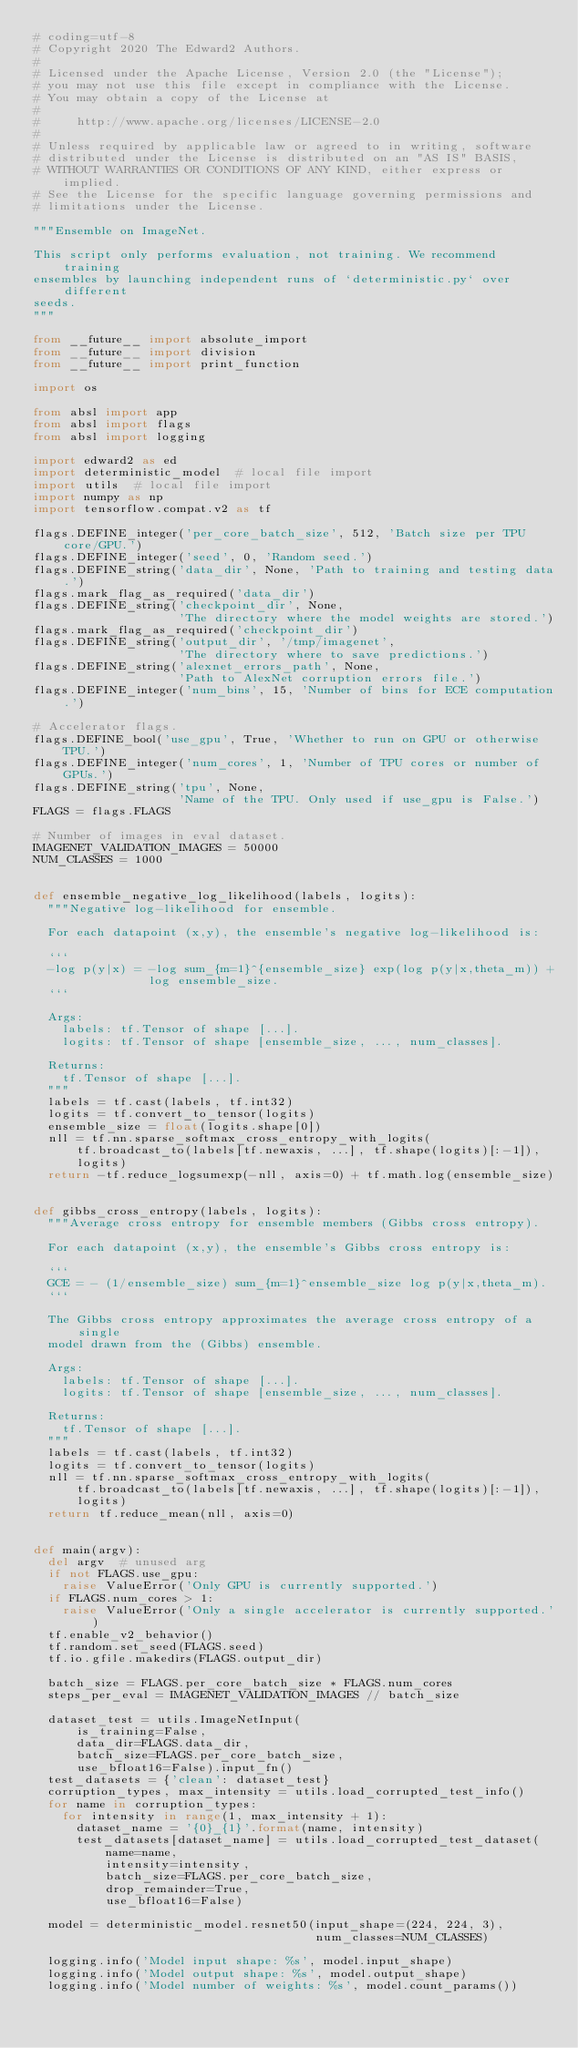Convert code to text. <code><loc_0><loc_0><loc_500><loc_500><_Python_># coding=utf-8
# Copyright 2020 The Edward2 Authors.
#
# Licensed under the Apache License, Version 2.0 (the "License");
# you may not use this file except in compliance with the License.
# You may obtain a copy of the License at
#
#     http://www.apache.org/licenses/LICENSE-2.0
#
# Unless required by applicable law or agreed to in writing, software
# distributed under the License is distributed on an "AS IS" BASIS,
# WITHOUT WARRANTIES OR CONDITIONS OF ANY KIND, either express or implied.
# See the License for the specific language governing permissions and
# limitations under the License.

"""Ensemble on ImageNet.

This script only performs evaluation, not training. We recommend training
ensembles by launching independent runs of `deterministic.py` over different
seeds.
"""

from __future__ import absolute_import
from __future__ import division
from __future__ import print_function

import os

from absl import app
from absl import flags
from absl import logging

import edward2 as ed
import deterministic_model  # local file import
import utils  # local file import
import numpy as np
import tensorflow.compat.v2 as tf

flags.DEFINE_integer('per_core_batch_size', 512, 'Batch size per TPU core/GPU.')
flags.DEFINE_integer('seed', 0, 'Random seed.')
flags.DEFINE_string('data_dir', None, 'Path to training and testing data.')
flags.mark_flag_as_required('data_dir')
flags.DEFINE_string('checkpoint_dir', None,
                    'The directory where the model weights are stored.')
flags.mark_flag_as_required('checkpoint_dir')
flags.DEFINE_string('output_dir', '/tmp/imagenet',
                    'The directory where to save predictions.')
flags.DEFINE_string('alexnet_errors_path', None,
                    'Path to AlexNet corruption errors file.')
flags.DEFINE_integer('num_bins', 15, 'Number of bins for ECE computation.')

# Accelerator flags.
flags.DEFINE_bool('use_gpu', True, 'Whether to run on GPU or otherwise TPU.')
flags.DEFINE_integer('num_cores', 1, 'Number of TPU cores or number of GPUs.')
flags.DEFINE_string('tpu', None,
                    'Name of the TPU. Only used if use_gpu is False.')
FLAGS = flags.FLAGS

# Number of images in eval dataset.
IMAGENET_VALIDATION_IMAGES = 50000
NUM_CLASSES = 1000


def ensemble_negative_log_likelihood(labels, logits):
  """Negative log-likelihood for ensemble.

  For each datapoint (x,y), the ensemble's negative log-likelihood is:

  ```
  -log p(y|x) = -log sum_{m=1}^{ensemble_size} exp(log p(y|x,theta_m)) +
                log ensemble_size.
  ```

  Args:
    labels: tf.Tensor of shape [...].
    logits: tf.Tensor of shape [ensemble_size, ..., num_classes].

  Returns:
    tf.Tensor of shape [...].
  """
  labels = tf.cast(labels, tf.int32)
  logits = tf.convert_to_tensor(logits)
  ensemble_size = float(logits.shape[0])
  nll = tf.nn.sparse_softmax_cross_entropy_with_logits(
      tf.broadcast_to(labels[tf.newaxis, ...], tf.shape(logits)[:-1]),
      logits)
  return -tf.reduce_logsumexp(-nll, axis=0) + tf.math.log(ensemble_size)


def gibbs_cross_entropy(labels, logits):
  """Average cross entropy for ensemble members (Gibbs cross entropy).

  For each datapoint (x,y), the ensemble's Gibbs cross entropy is:

  ```
  GCE = - (1/ensemble_size) sum_{m=1}^ensemble_size log p(y|x,theta_m).
  ```

  The Gibbs cross entropy approximates the average cross entropy of a single
  model drawn from the (Gibbs) ensemble.

  Args:
    labels: tf.Tensor of shape [...].
    logits: tf.Tensor of shape [ensemble_size, ..., num_classes].

  Returns:
    tf.Tensor of shape [...].
  """
  labels = tf.cast(labels, tf.int32)
  logits = tf.convert_to_tensor(logits)
  nll = tf.nn.sparse_softmax_cross_entropy_with_logits(
      tf.broadcast_to(labels[tf.newaxis, ...], tf.shape(logits)[:-1]),
      logits)
  return tf.reduce_mean(nll, axis=0)


def main(argv):
  del argv  # unused arg
  if not FLAGS.use_gpu:
    raise ValueError('Only GPU is currently supported.')
  if FLAGS.num_cores > 1:
    raise ValueError('Only a single accelerator is currently supported.')
  tf.enable_v2_behavior()
  tf.random.set_seed(FLAGS.seed)
  tf.io.gfile.makedirs(FLAGS.output_dir)

  batch_size = FLAGS.per_core_batch_size * FLAGS.num_cores
  steps_per_eval = IMAGENET_VALIDATION_IMAGES // batch_size

  dataset_test = utils.ImageNetInput(
      is_training=False,
      data_dir=FLAGS.data_dir,
      batch_size=FLAGS.per_core_batch_size,
      use_bfloat16=False).input_fn()
  test_datasets = {'clean': dataset_test}
  corruption_types, max_intensity = utils.load_corrupted_test_info()
  for name in corruption_types:
    for intensity in range(1, max_intensity + 1):
      dataset_name = '{0}_{1}'.format(name, intensity)
      test_datasets[dataset_name] = utils.load_corrupted_test_dataset(
          name=name,
          intensity=intensity,
          batch_size=FLAGS.per_core_batch_size,
          drop_remainder=True,
          use_bfloat16=False)

  model = deterministic_model.resnet50(input_shape=(224, 224, 3),
                                       num_classes=NUM_CLASSES)

  logging.info('Model input shape: %s', model.input_shape)
  logging.info('Model output shape: %s', model.output_shape)
  logging.info('Model number of weights: %s', model.count_params())</code> 